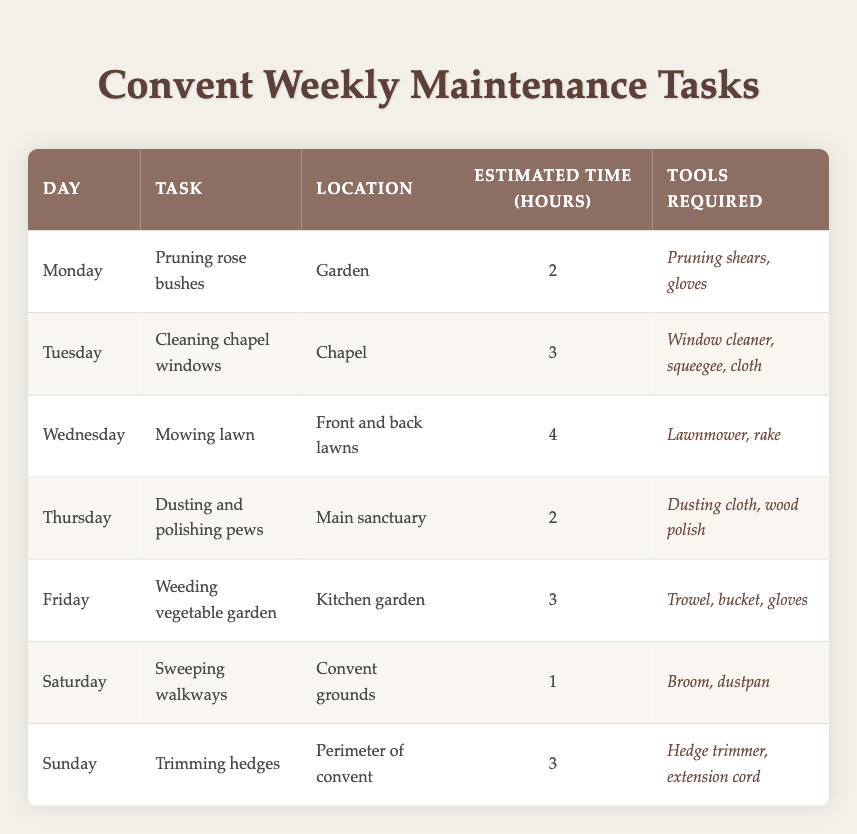What task is scheduled for Wednesday? By looking at the table, the task listed under Wednesday is "Mowing lawn."
Answer: Mowing lawn How long is the task of weeding vegetable garden expected to take? The table shows that weeding the vegetable garden is estimated to take 3 hours.
Answer: 3 hours Which task requires the most time to complete? The task with the longest estimated time is "Mowing lawn," which takes 4 hours.
Answer: Mowing lawn Is dusting and polishing pews scheduled on Tuesday? Referring to the table, dusting and polishing pews is scheduled for Thursday, not Tuesday.
Answer: No What tools are needed for sweeping walkways? According to the table, the tools required for sweeping walkways are "Broom, dustpan."
Answer: Broom, dustpan What is the total estimated time for maintenance tasks on the weekend? The weekend tasks include sweeping walkways on Saturday (1 hour) and trimming hedges on Sunday (3 hours). Adding these gives a total of 1 + 3 = 4 hours.
Answer: 4 hours Does the gardening work occur during the week? The table lists two gardening-related tasks: "Pruning rose bushes" on Monday and "Weeding vegetable garden" on Friday, confirming that gardening work occurs during the week.
Answer: Yes Which location has the most maintenance tasks scheduled this week? The locations mentioned in the table are Garden, Chapel, Front and back lawns, Main sanctuary, Kitchen garden, and Convent grounds. Each has one task, with none appearing more than once. Thus, all locations have the same number of scheduled tasks.
Answer: All locations have one task 